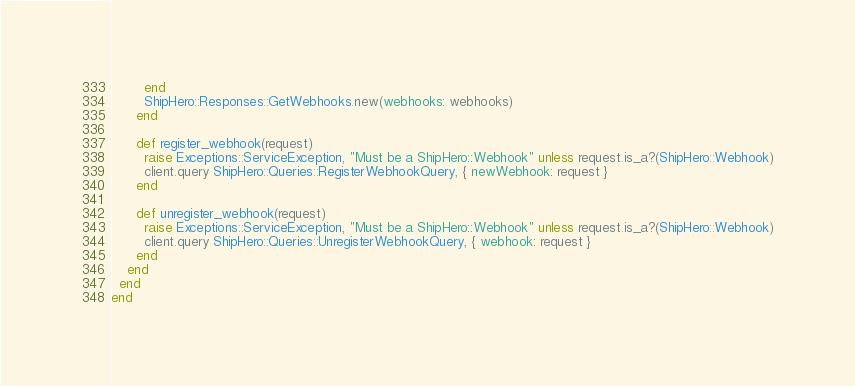Convert code to text. <code><loc_0><loc_0><loc_500><loc_500><_Ruby_>        end
        ShipHero::Responses::GetWebhooks.new(webhooks: webhooks)
      end

      def register_webhook(request)
        raise Exceptions::ServiceException, "Must be a ShipHero::Webhook" unless request.is_a?(ShipHero::Webhook)
        client.query ShipHero::Queries::RegisterWebhookQuery, { newWebhook: request }
      end

      def unregister_webhook(request)
        raise Exceptions::ServiceException, "Must be a ShipHero::Webhook" unless request.is_a?(ShipHero::Webhook)
        client.query ShipHero::Queries::UnregisterWebhookQuery, { webhook: request }
      end
    end
  end
end
</code> 